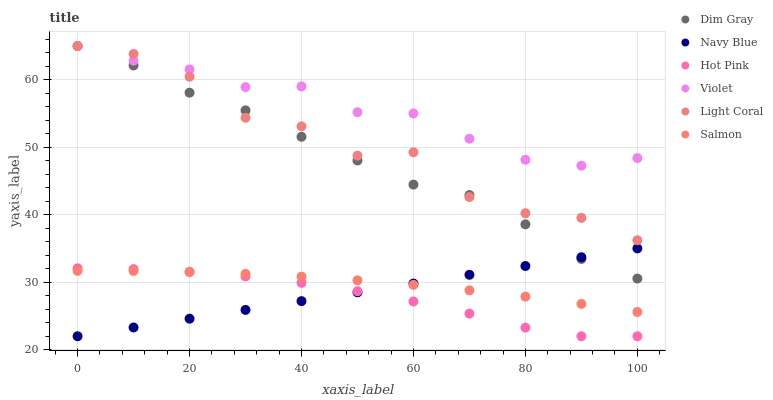Does Hot Pink have the minimum area under the curve?
Answer yes or no. Yes. Does Violet have the maximum area under the curve?
Answer yes or no. Yes. Does Navy Blue have the minimum area under the curve?
Answer yes or no. No. Does Navy Blue have the maximum area under the curve?
Answer yes or no. No. Is Navy Blue the smoothest?
Answer yes or no. Yes. Is Light Coral the roughest?
Answer yes or no. Yes. Is Hot Pink the smoothest?
Answer yes or no. No. Is Hot Pink the roughest?
Answer yes or no. No. Does Navy Blue have the lowest value?
Answer yes or no. Yes. Does Salmon have the lowest value?
Answer yes or no. No. Does Violet have the highest value?
Answer yes or no. Yes. Does Navy Blue have the highest value?
Answer yes or no. No. Is Salmon less than Violet?
Answer yes or no. Yes. Is Dim Gray greater than Salmon?
Answer yes or no. Yes. Does Violet intersect Light Coral?
Answer yes or no. Yes. Is Violet less than Light Coral?
Answer yes or no. No. Is Violet greater than Light Coral?
Answer yes or no. No. Does Salmon intersect Violet?
Answer yes or no. No. 